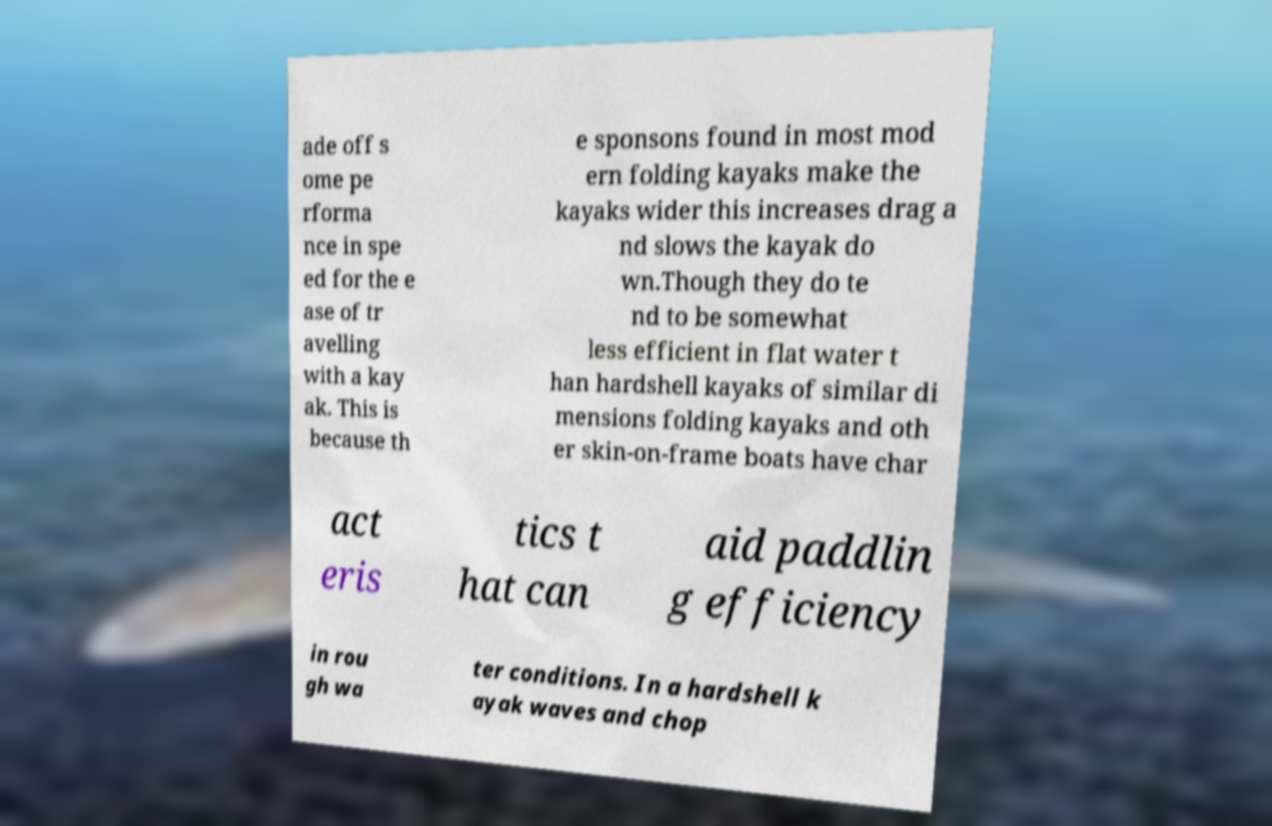Please read and relay the text visible in this image. What does it say? ade off s ome pe rforma nce in spe ed for the e ase of tr avelling with a kay ak. This is because th e sponsons found in most mod ern folding kayaks make the kayaks wider this increases drag a nd slows the kayak do wn.Though they do te nd to be somewhat less efficient in flat water t han hardshell kayaks of similar di mensions folding kayaks and oth er skin-on-frame boats have char act eris tics t hat can aid paddlin g efficiency in rou gh wa ter conditions. In a hardshell k ayak waves and chop 